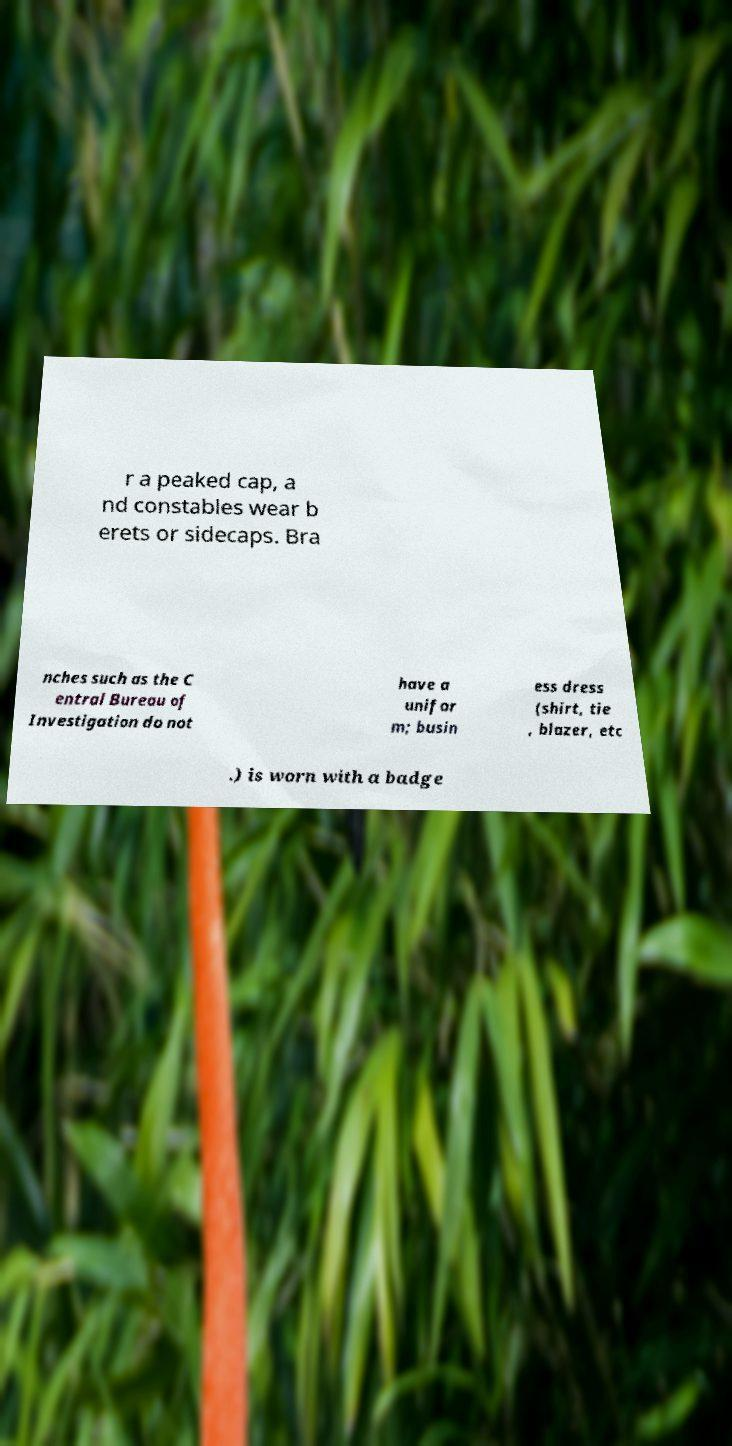Can you accurately transcribe the text from the provided image for me? r a peaked cap, a nd constables wear b erets or sidecaps. Bra nches such as the C entral Bureau of Investigation do not have a unifor m; busin ess dress (shirt, tie , blazer, etc .) is worn with a badge 